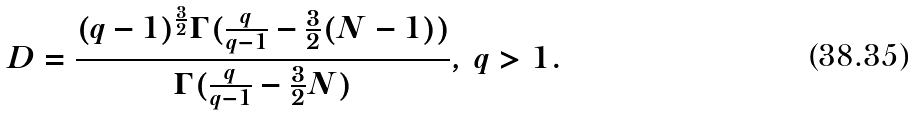<formula> <loc_0><loc_0><loc_500><loc_500>D = \frac { ( q - 1 ) ^ { \frac { 3 } { 2 } } \Gamma ( \frac { q } { q - 1 } - \frac { 3 } { 2 } ( N - 1 ) ) } { \Gamma ( \frac { q } { q - 1 } - \frac { 3 } { 2 } N ) } , \, q > 1 .</formula> 